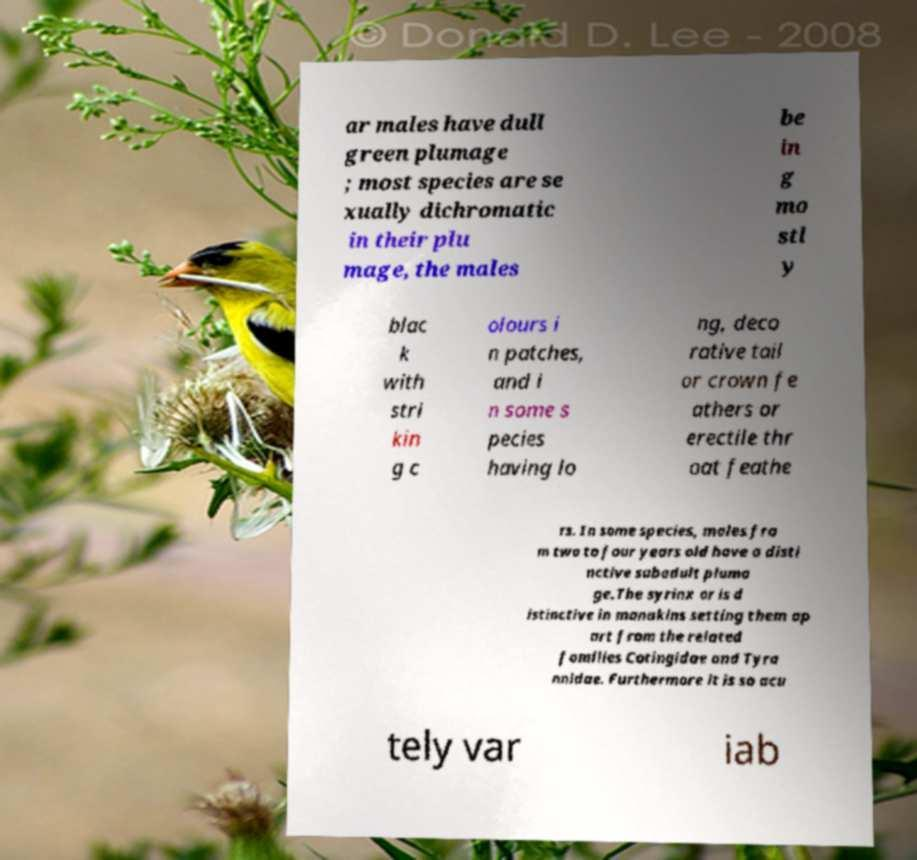For documentation purposes, I need the text within this image transcribed. Could you provide that? ar males have dull green plumage ; most species are se xually dichromatic in their plu mage, the males be in g mo stl y blac k with stri kin g c olours i n patches, and i n some s pecies having lo ng, deco rative tail or crown fe athers or erectile thr oat feathe rs. In some species, males fro m two to four years old have a disti nctive subadult pluma ge.The syrinx or is d istinctive in manakins setting them ap art from the related families Cotingidae and Tyra nnidae. Furthermore it is so acu tely var iab 